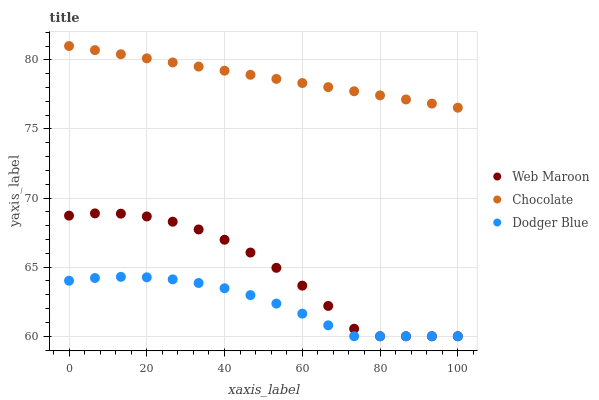Does Dodger Blue have the minimum area under the curve?
Answer yes or no. Yes. Does Chocolate have the maximum area under the curve?
Answer yes or no. Yes. Does Web Maroon have the minimum area under the curve?
Answer yes or no. No. Does Web Maroon have the maximum area under the curve?
Answer yes or no. No. Is Chocolate the smoothest?
Answer yes or no. Yes. Is Web Maroon the roughest?
Answer yes or no. Yes. Is Web Maroon the smoothest?
Answer yes or no. No. Is Chocolate the roughest?
Answer yes or no. No. Does Dodger Blue have the lowest value?
Answer yes or no. Yes. Does Chocolate have the lowest value?
Answer yes or no. No. Does Chocolate have the highest value?
Answer yes or no. Yes. Does Web Maroon have the highest value?
Answer yes or no. No. Is Dodger Blue less than Chocolate?
Answer yes or no. Yes. Is Chocolate greater than Dodger Blue?
Answer yes or no. Yes. Does Web Maroon intersect Dodger Blue?
Answer yes or no. Yes. Is Web Maroon less than Dodger Blue?
Answer yes or no. No. Is Web Maroon greater than Dodger Blue?
Answer yes or no. No. Does Dodger Blue intersect Chocolate?
Answer yes or no. No. 